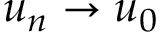<formula> <loc_0><loc_0><loc_500><loc_500>u _ { n } \to u _ { 0 }</formula> 